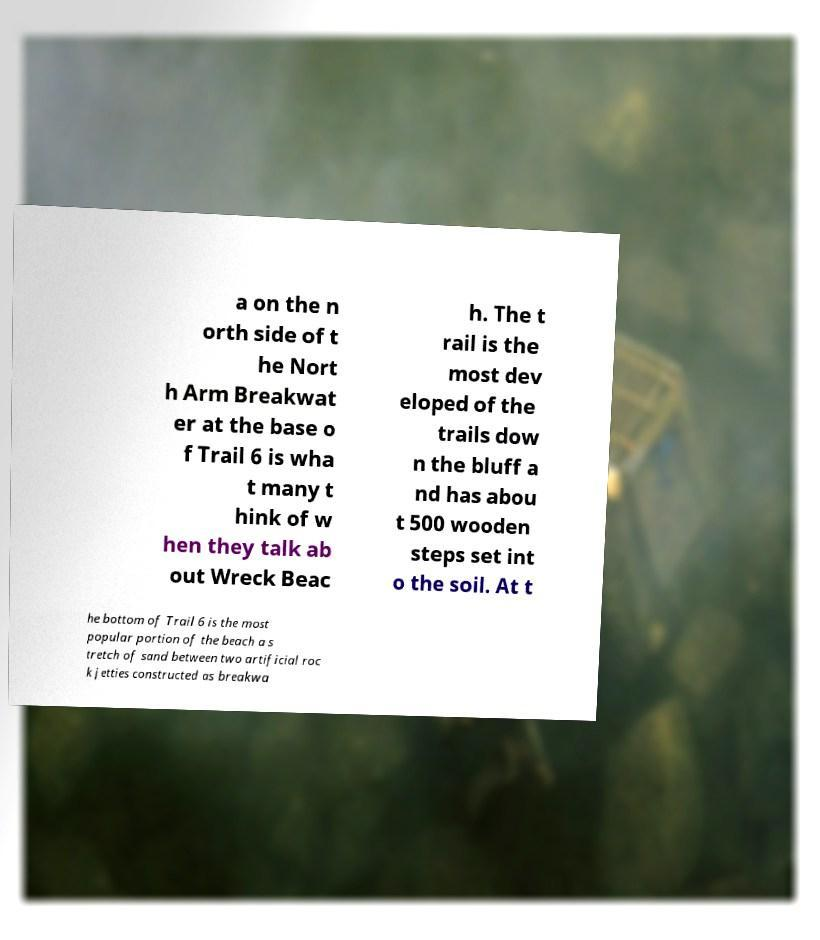Could you assist in decoding the text presented in this image and type it out clearly? a on the n orth side of t he Nort h Arm Breakwat er at the base o f Trail 6 is wha t many t hink of w hen they talk ab out Wreck Beac h. The t rail is the most dev eloped of the trails dow n the bluff a nd has abou t 500 wooden steps set int o the soil. At t he bottom of Trail 6 is the most popular portion of the beach a s tretch of sand between two artificial roc k jetties constructed as breakwa 